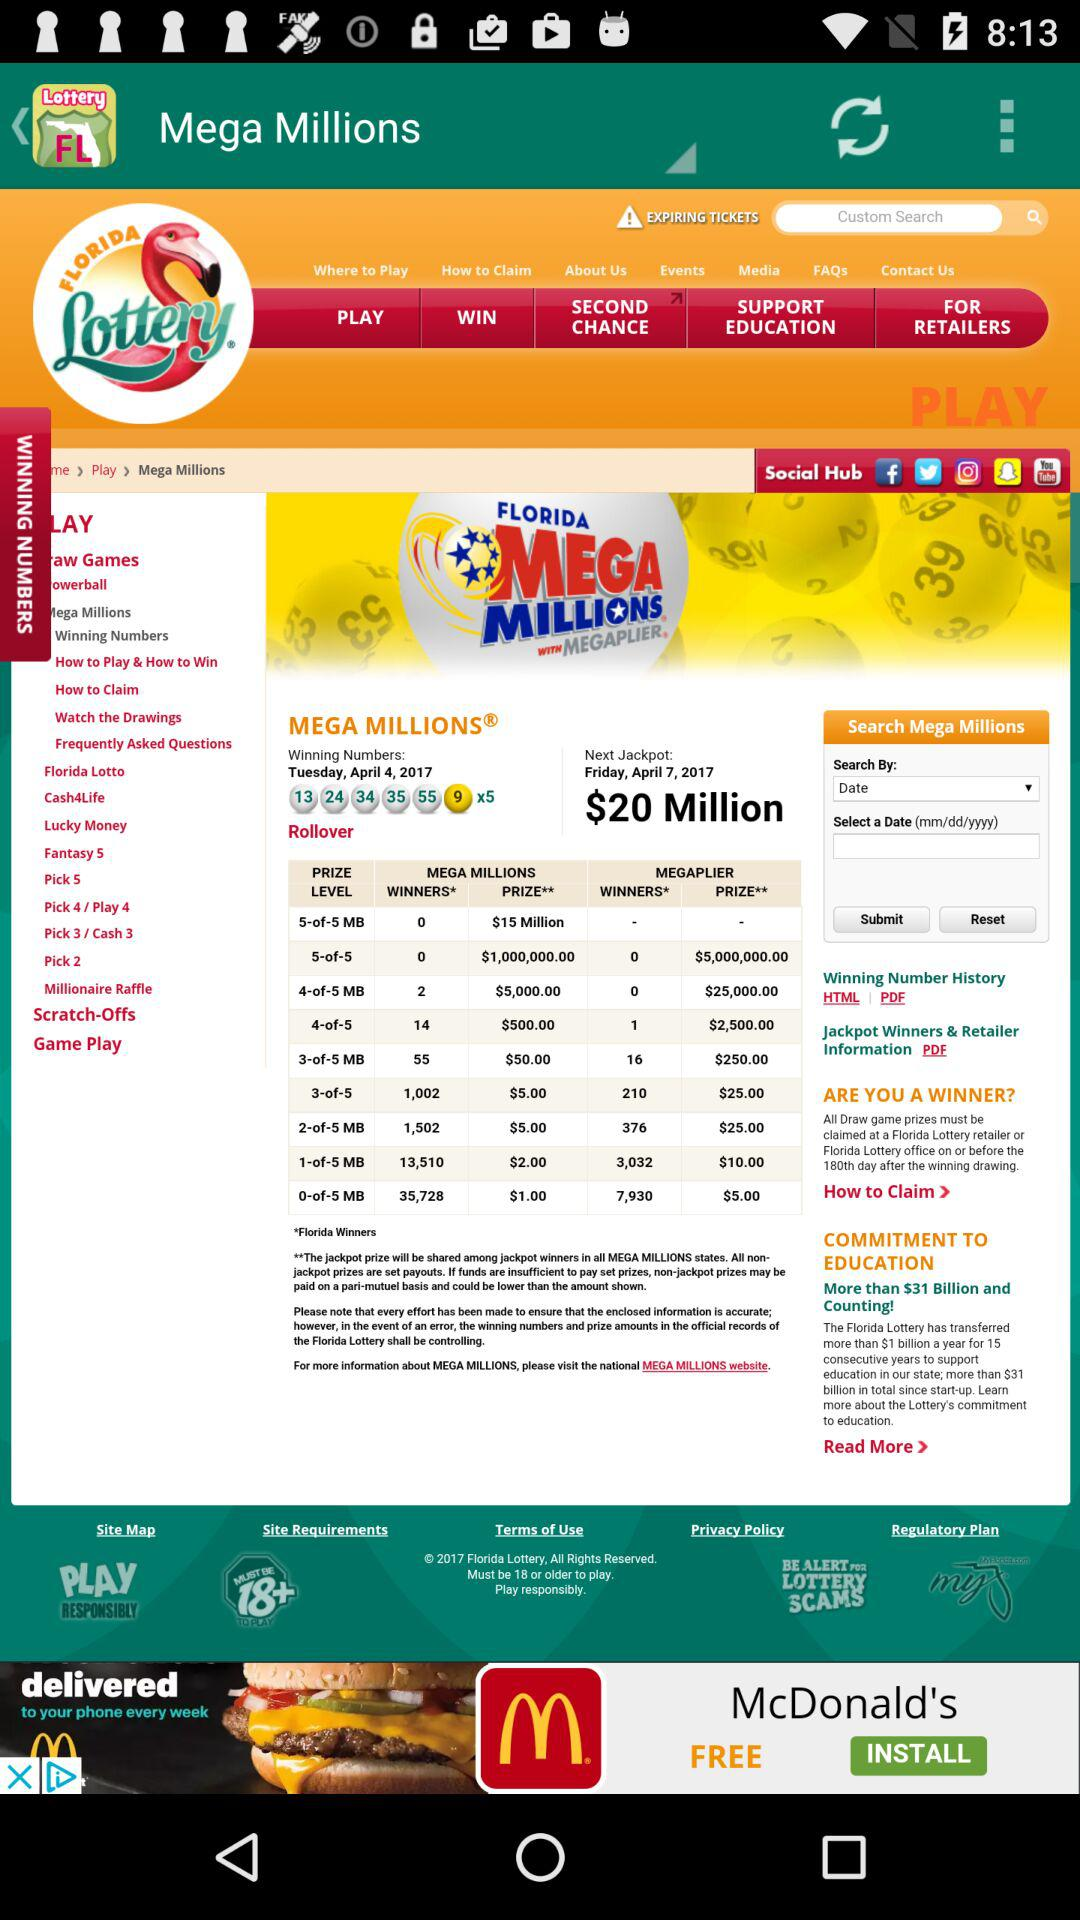What is the application name? The application name is "Florida Lottery". 